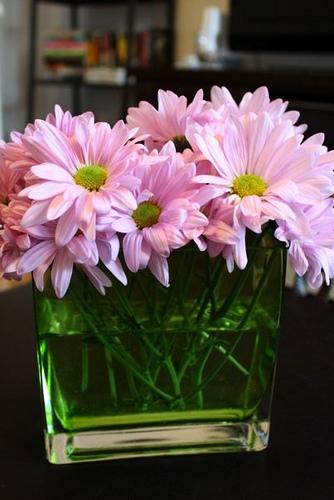What color are the flowers?
Concise answer only. Pink. Are these daisies?
Concise answer only. Yes. Are the flowers in water?
Answer briefly. Yes. 